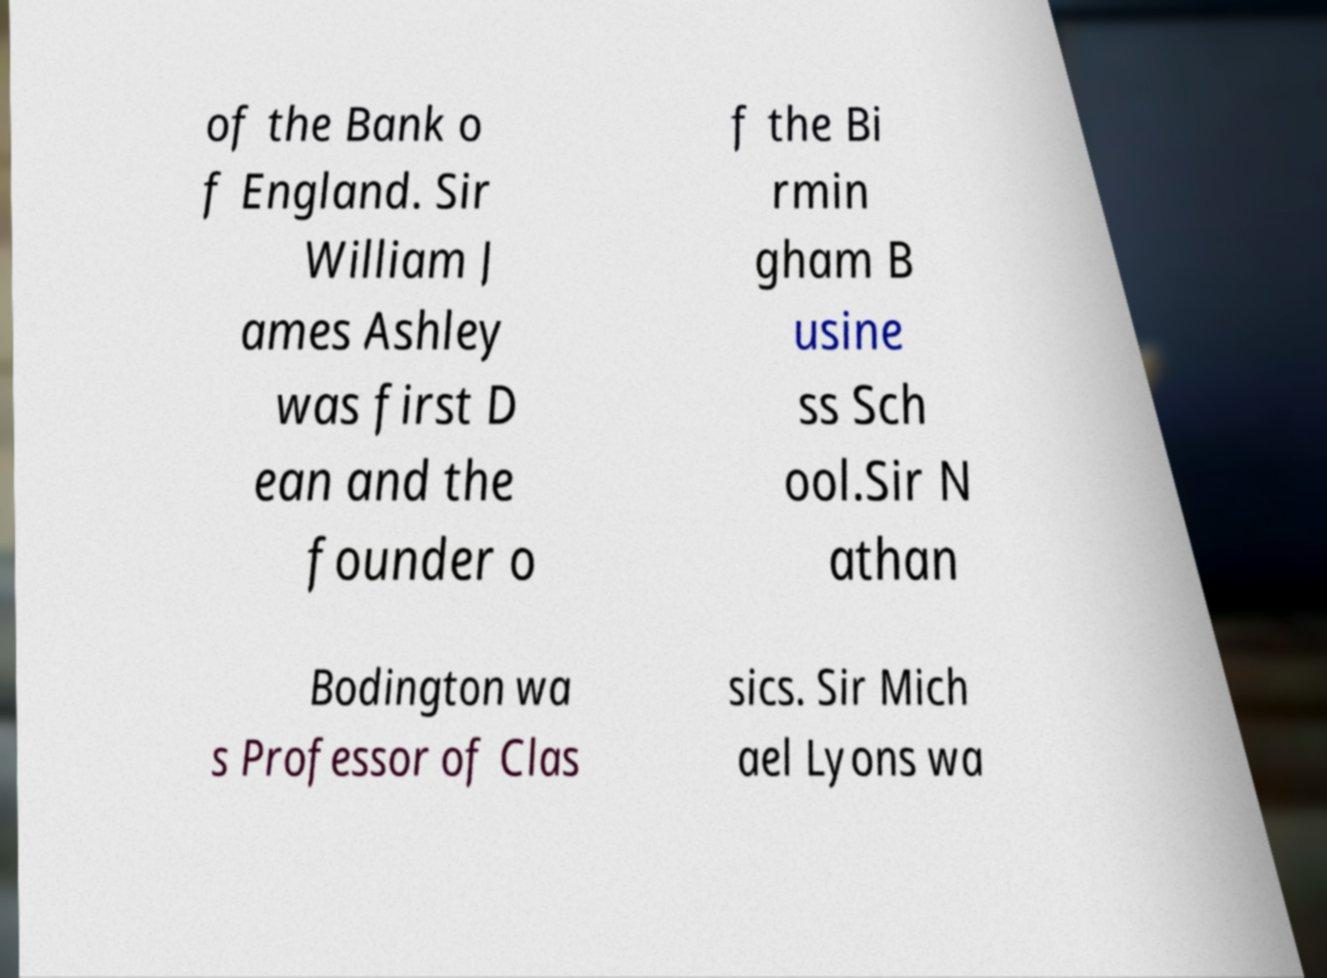Can you accurately transcribe the text from the provided image for me? of the Bank o f England. Sir William J ames Ashley was first D ean and the founder o f the Bi rmin gham B usine ss Sch ool.Sir N athan Bodington wa s Professor of Clas sics. Sir Mich ael Lyons wa 